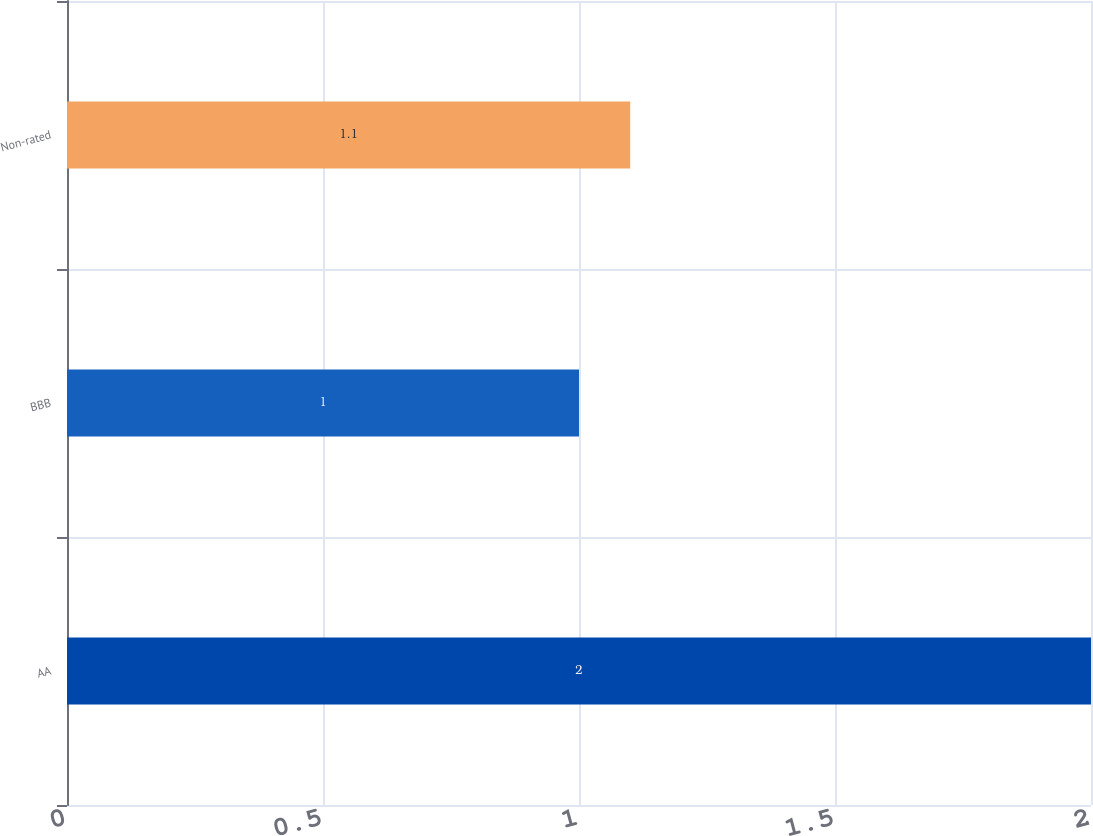<chart> <loc_0><loc_0><loc_500><loc_500><bar_chart><fcel>AA<fcel>BBB<fcel>Non-rated<nl><fcel>2<fcel>1<fcel>1.1<nl></chart> 